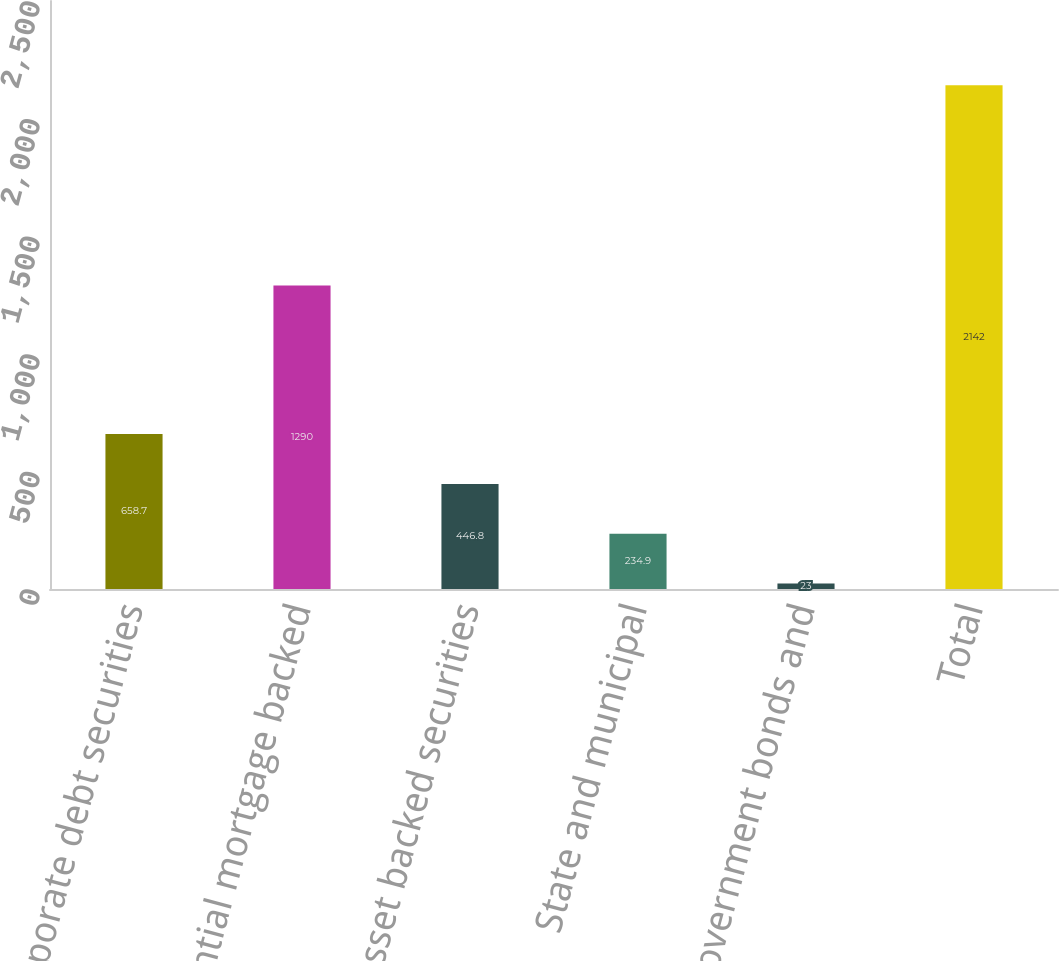<chart> <loc_0><loc_0><loc_500><loc_500><bar_chart><fcel>Corporate debt securities<fcel>Residential mortgage backed<fcel>Asset backed securities<fcel>State and municipal<fcel>Foreign government bonds and<fcel>Total<nl><fcel>658.7<fcel>1290<fcel>446.8<fcel>234.9<fcel>23<fcel>2142<nl></chart> 